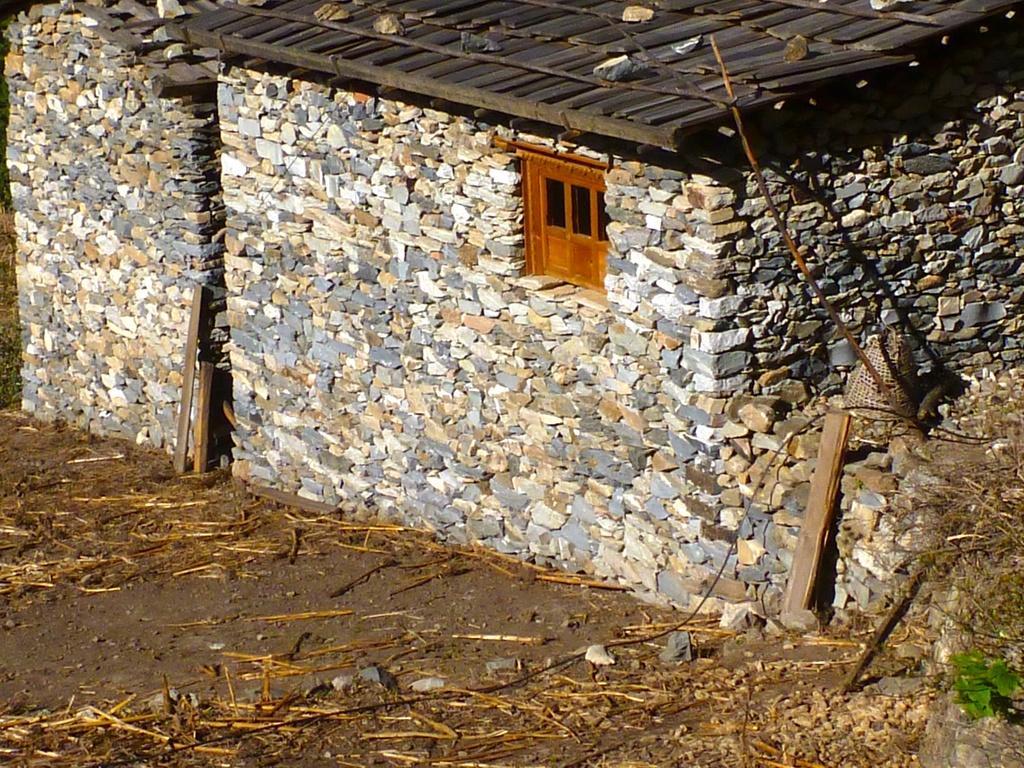Could you give a brief overview of what you see in this image? In this picture there is a house which is made of few rocks and there is a wooden door in between it and there are few rocks on the roof and there are some other objects in the right corner. 